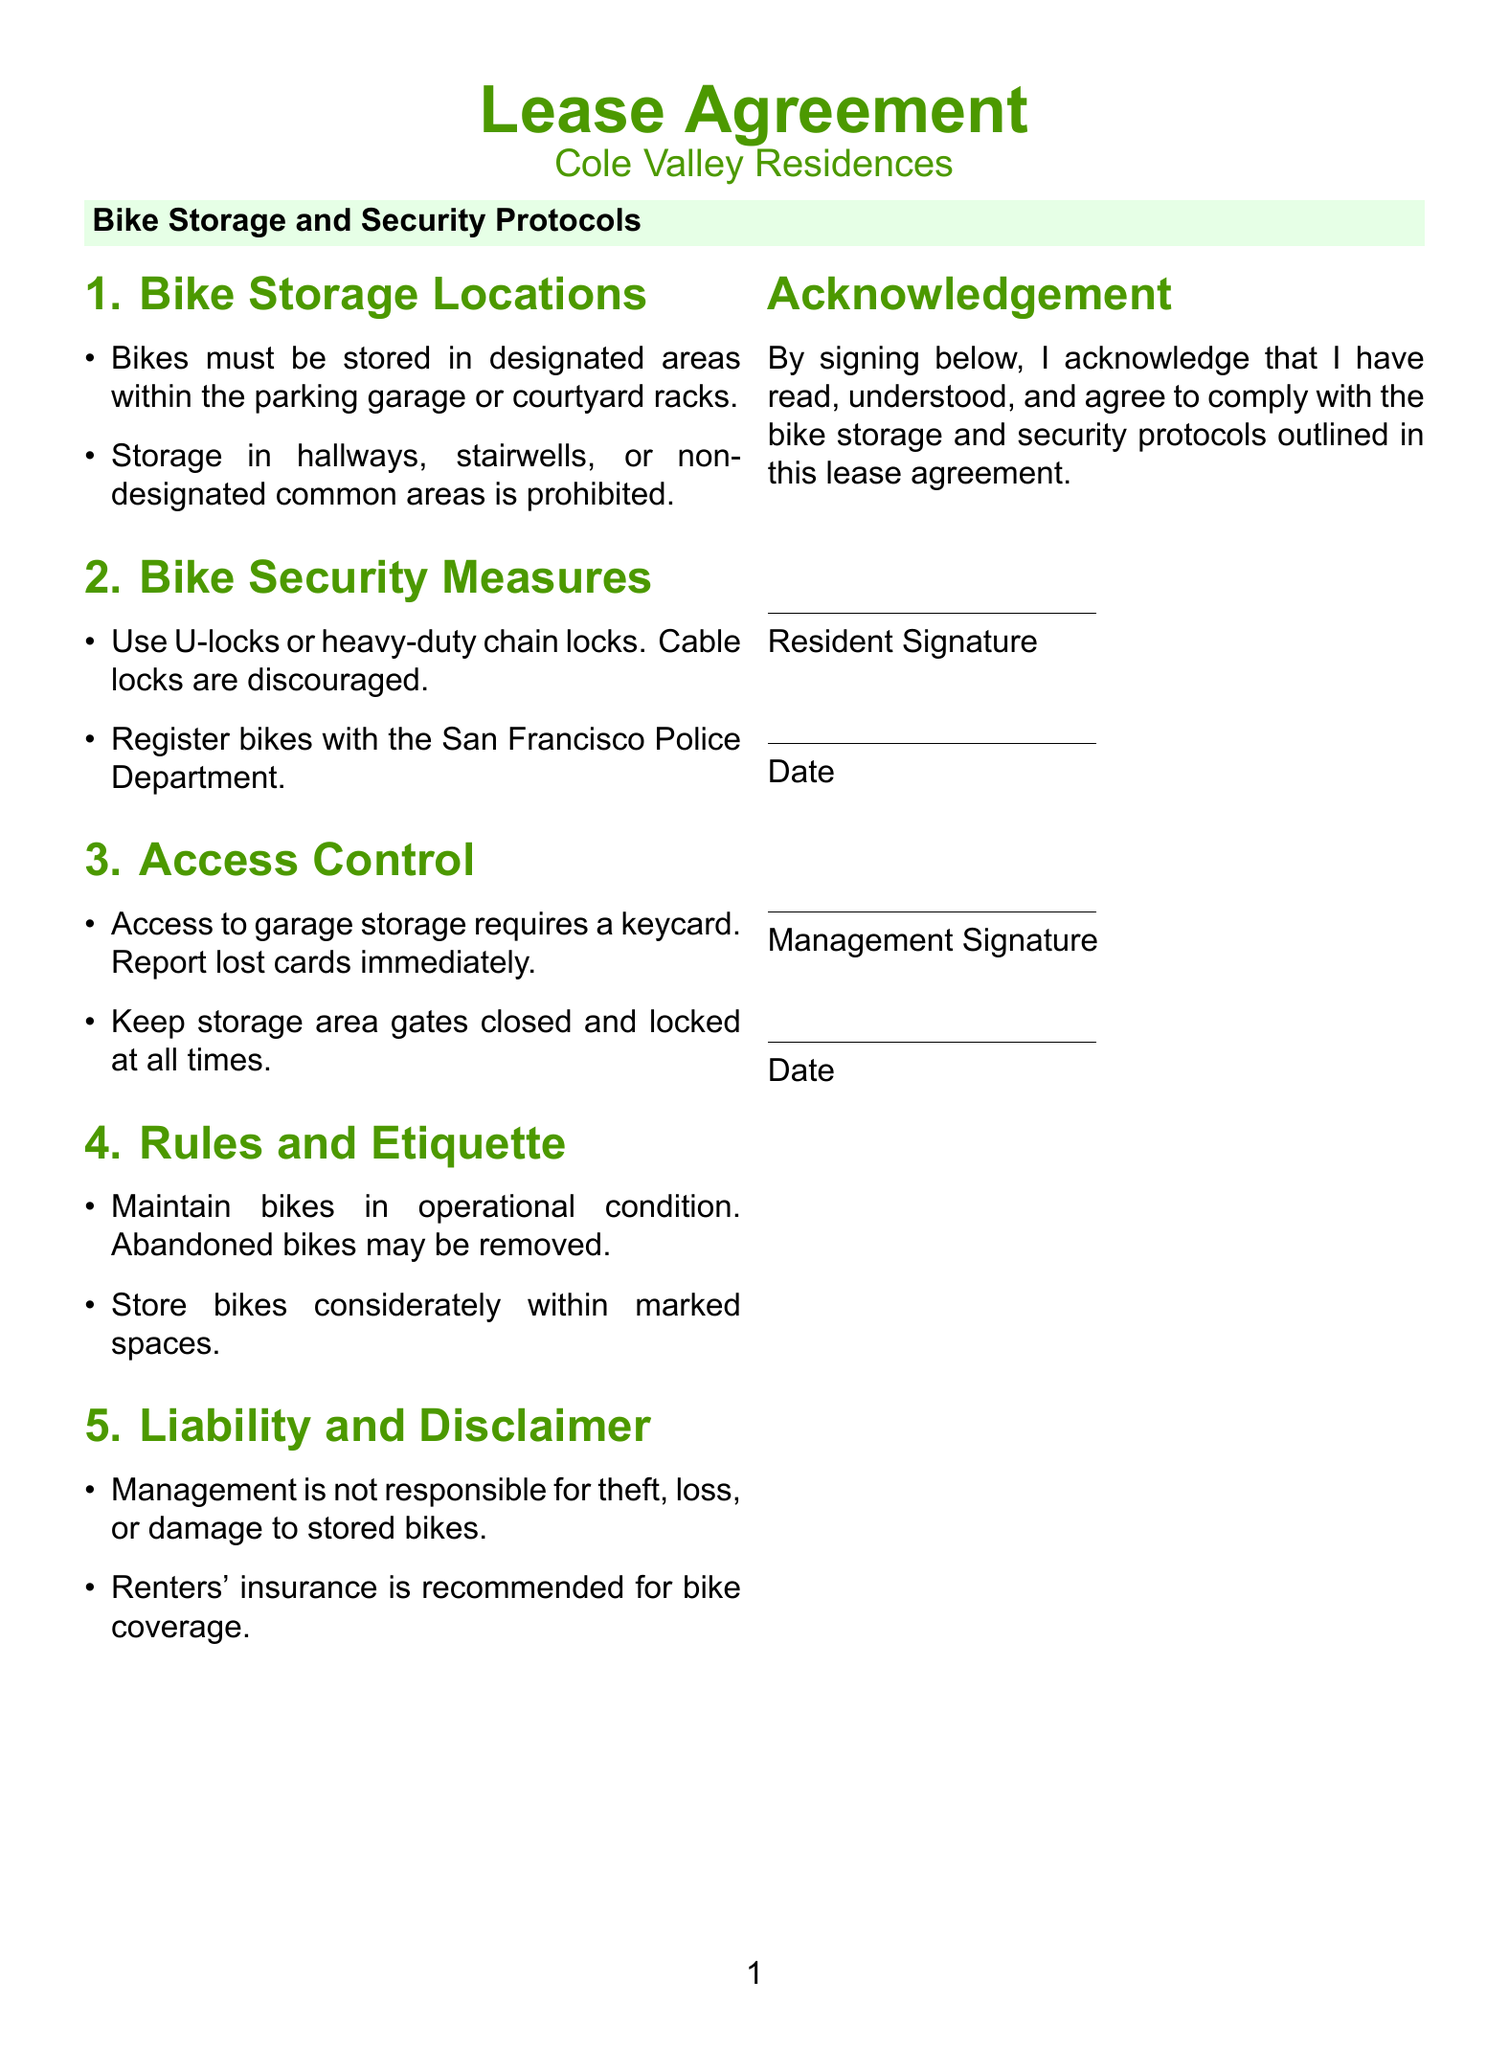What are the designated bike storage locations? The document specifies that bikes must be stored in designated areas within the parking garage or courtyard racks.
Answer: Parking garage or courtyard racks What type of locks are discouraged? The document mentions that cable locks are discouraged while recommending U-locks or heavy-duty chain locks.
Answer: Cable locks Who should bikes be registered with? The document states that bikes should be registered with the San Francisco Police Department.
Answer: San Francisco Police Department What is required for access to garage storage? According to the document, access to garage storage requires a keycard and lost cards must be reported immediately.
Answer: Keycard What is the policy on abandoned bikes? The document indicates that abandoned bikes may be removed and residents must maintain bikes in operational condition.
Answer: Abandoned bikes may be removed What is the liability disclaimer regarding stored bikes? The lease agreement states that management is not responsible for theft, loss, or damage to stored bikes.
Answer: Not responsible for theft, loss, or damage What is recommended for bike coverage? The document recommends renters' insurance for bike coverage.
Answer: Renters' insurance How must bikes be stored? The document requires that bikes be stored considerately within marked spaces.
Answer: Stored considerately within marked spaces What must residents do if they lose their keycard? The document emphasizes the need to report lost keycards immediately.
Answer: Report lost cards immediately 